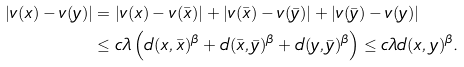<formula> <loc_0><loc_0><loc_500><loc_500>| v ( x ) - v ( y ) | & = | v ( x ) - v ( \bar { x } ) | + | v ( \bar { x } ) - v ( \bar { y } ) | + | v ( \bar { y } ) - v ( y ) | \\ & \leq c \lambda \left ( d ( x , \bar { x } ) ^ { \beta } + d ( \bar { x } , \bar { y } ) ^ { \beta } + d ( y , \bar { y } ) ^ { \beta } \right ) \leq c \lambda d ( x , y ) ^ { \beta } .</formula> 